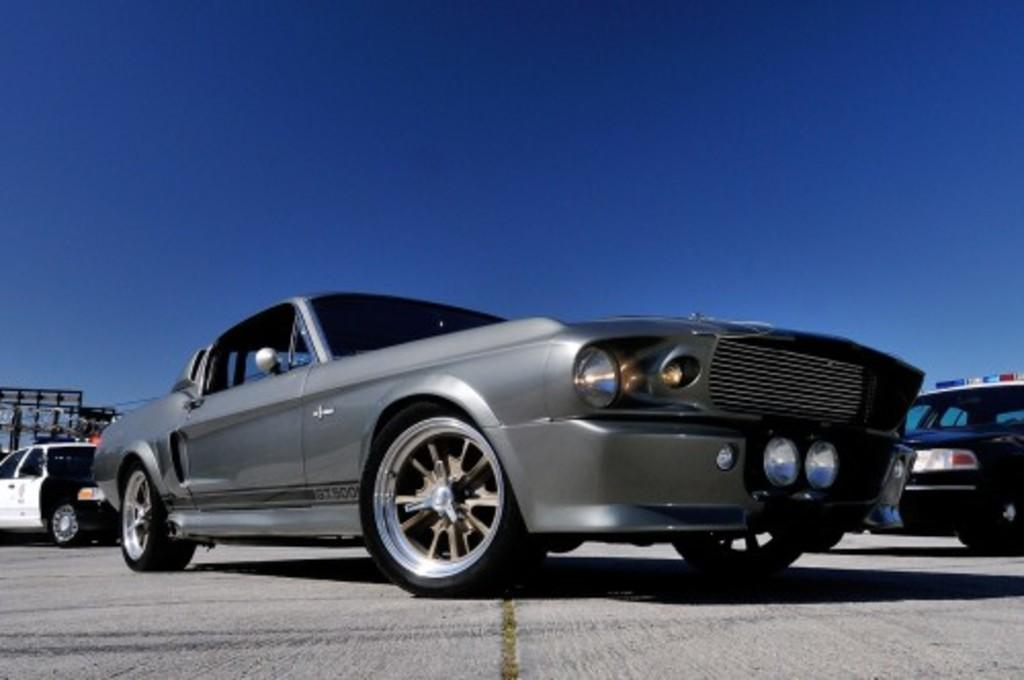What type of vehicles can be seen in the image? There are cars in the image. What is visible at the top of the image? The sky is visible at the top of the image. What is the color of the sky in the image? The color of the sky is blue. How does the death of the cars affect the traffic in the image? There is no indication of any death or traffic in the image, as it only features cars and the blue sky. 